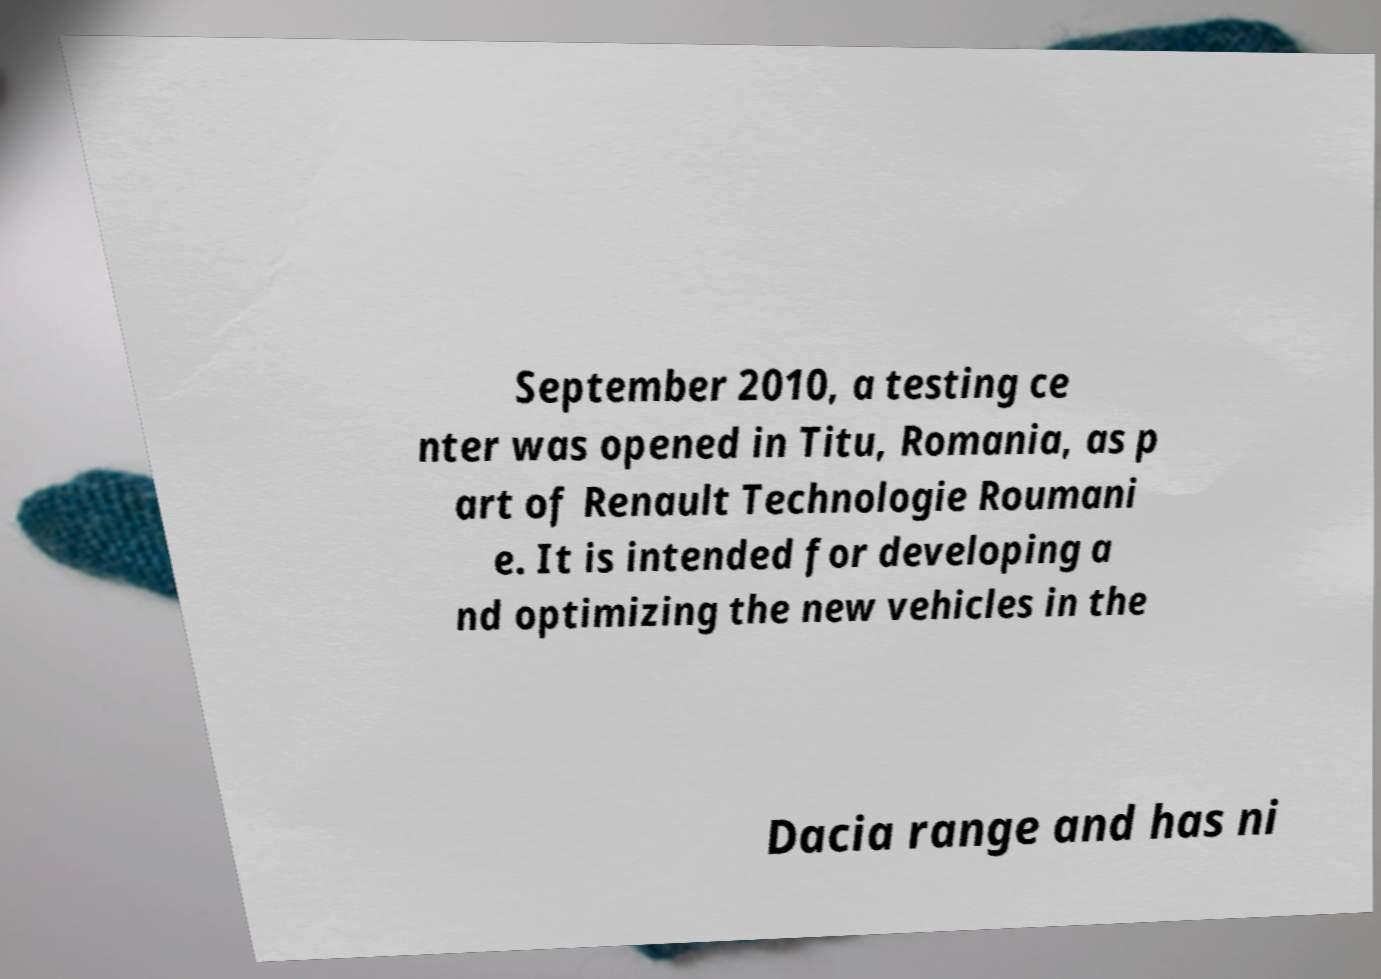There's text embedded in this image that I need extracted. Can you transcribe it verbatim? September 2010, a testing ce nter was opened in Titu, Romania, as p art of Renault Technologie Roumani e. It is intended for developing a nd optimizing the new vehicles in the Dacia range and has ni 